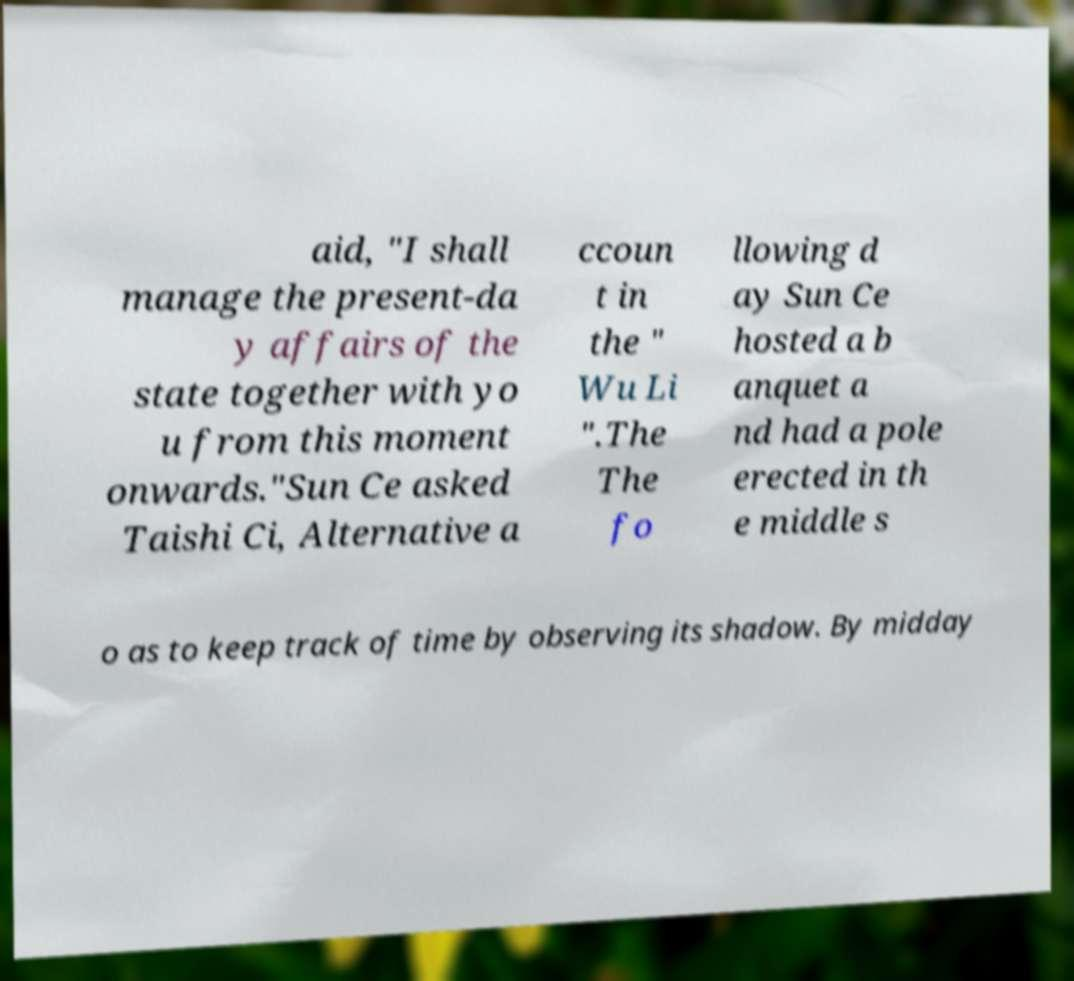Could you assist in decoding the text presented in this image and type it out clearly? aid, "I shall manage the present-da y affairs of the state together with yo u from this moment onwards."Sun Ce asked Taishi Ci, Alternative a ccoun t in the " Wu Li ".The The fo llowing d ay Sun Ce hosted a b anquet a nd had a pole erected in th e middle s o as to keep track of time by observing its shadow. By midday 